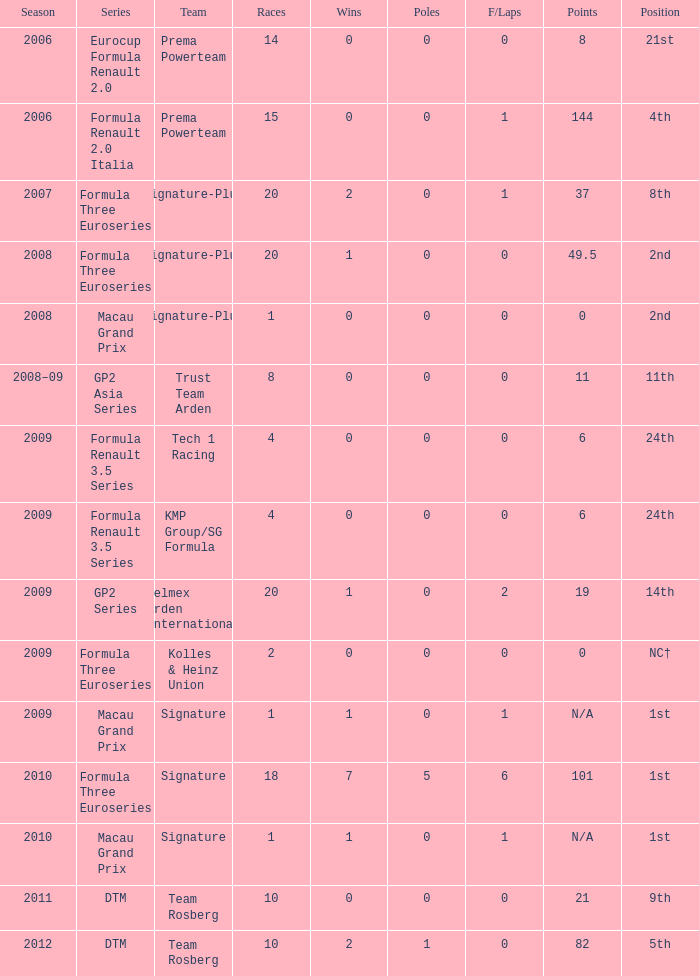How many races did the Formula Three Euroseries signature team have? 18.0. 